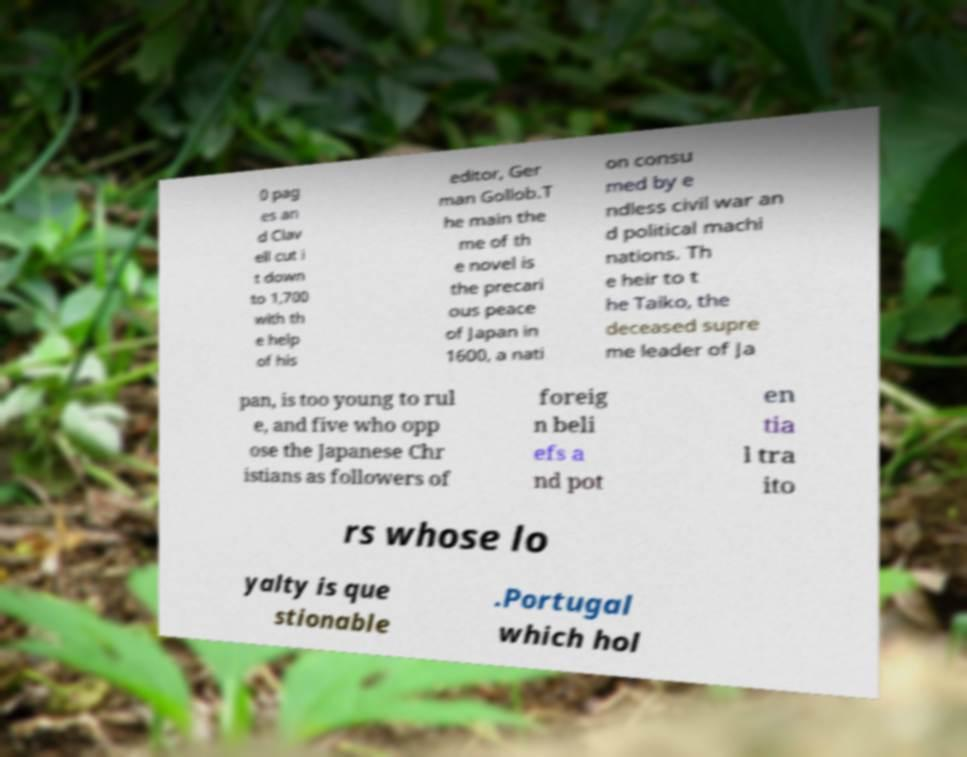Could you extract and type out the text from this image? 0 pag es an d Clav ell cut i t down to 1,700 with th e help of his editor, Ger man Gollob.T he main the me of th e novel is the precari ous peace of Japan in 1600, a nati on consu med by e ndless civil war an d political machi nations. Th e heir to t he Taiko, the deceased supre me leader of Ja pan, is too young to rul e, and five who opp ose the Japanese Chr istians as followers of foreig n beli efs a nd pot en tia l tra ito rs whose lo yalty is que stionable .Portugal which hol 